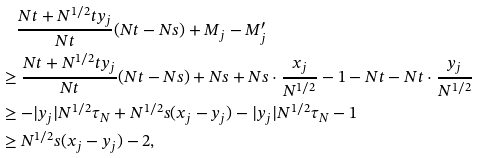<formula> <loc_0><loc_0><loc_500><loc_500>& \quad \frac { N t + N ^ { 1 / 2 } t y _ { j } } { N t } ( N t - N s ) + M _ { j } - M _ { j } ^ { \prime } \\ & \geq \frac { N t + N ^ { 1 / 2 } t y _ { j } } { N t } ( N t - N s ) + N s + N s \cdot \frac { x _ { j } } { N ^ { 1 / 2 } } - 1 - N t - N t \cdot \frac { y _ { j } } { N ^ { 1 / 2 } } \\ & \geq - | y _ { j } | N ^ { 1 / 2 } \tau _ { N } + N ^ { 1 / 2 } s ( x _ { j } - y _ { j } ) - | y _ { j } | N ^ { 1 / 2 } \tau _ { N } - 1 \\ & \geq N ^ { 1 / 2 } s ( x _ { j } - y _ { j } ) - 2 ,</formula> 